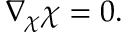Convert formula to latex. <formula><loc_0><loc_0><loc_500><loc_500>\nabla _ { \chi } { \chi } = 0 .</formula> 